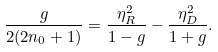Convert formula to latex. <formula><loc_0><loc_0><loc_500><loc_500>\frac { g } { 2 ( 2 n _ { 0 } + 1 ) } = \frac { \eta _ { R } ^ { 2 } } { 1 - g } - \frac { \eta _ { D } ^ { 2 } } { 1 + g } .</formula> 